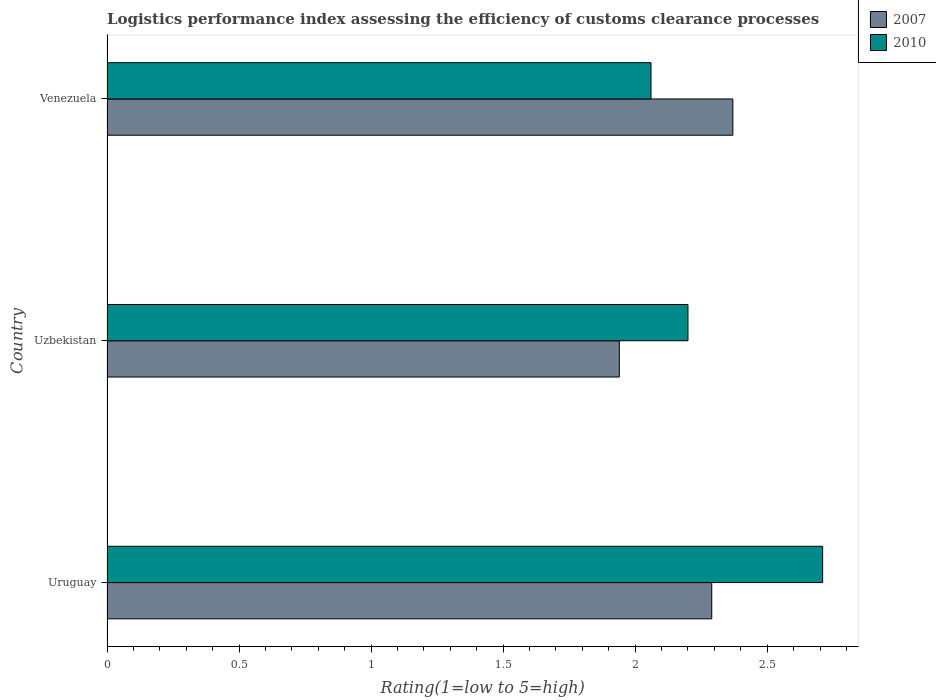How many different coloured bars are there?
Provide a short and direct response. 2. How many groups of bars are there?
Provide a short and direct response. 3. Are the number of bars per tick equal to the number of legend labels?
Offer a very short reply. Yes. Are the number of bars on each tick of the Y-axis equal?
Provide a succinct answer. Yes. How many bars are there on the 1st tick from the top?
Make the answer very short. 2. How many bars are there on the 3rd tick from the bottom?
Offer a very short reply. 2. What is the label of the 1st group of bars from the top?
Make the answer very short. Venezuela. What is the Logistic performance index in 2007 in Venezuela?
Provide a short and direct response. 2.37. Across all countries, what is the maximum Logistic performance index in 2010?
Provide a short and direct response. 2.71. Across all countries, what is the minimum Logistic performance index in 2010?
Offer a very short reply. 2.06. In which country was the Logistic performance index in 2010 maximum?
Your response must be concise. Uruguay. In which country was the Logistic performance index in 2007 minimum?
Your response must be concise. Uzbekistan. What is the total Logistic performance index in 2007 in the graph?
Your response must be concise. 6.6. What is the difference between the Logistic performance index in 2010 in Uruguay and that in Uzbekistan?
Make the answer very short. 0.51. What is the difference between the Logistic performance index in 2007 in Venezuela and the Logistic performance index in 2010 in Uruguay?
Provide a short and direct response. -0.34. What is the average Logistic performance index in 2007 per country?
Your answer should be compact. 2.2. What is the difference between the Logistic performance index in 2007 and Logistic performance index in 2010 in Venezuela?
Ensure brevity in your answer.  0.31. In how many countries, is the Logistic performance index in 2007 greater than 2.3 ?
Provide a short and direct response. 1. What is the ratio of the Logistic performance index in 2007 in Uruguay to that in Venezuela?
Provide a succinct answer. 0.97. What is the difference between the highest and the second highest Logistic performance index in 2010?
Make the answer very short. 0.51. What is the difference between the highest and the lowest Logistic performance index in 2010?
Offer a very short reply. 0.65. In how many countries, is the Logistic performance index in 2007 greater than the average Logistic performance index in 2007 taken over all countries?
Your response must be concise. 2. Is the sum of the Logistic performance index in 2010 in Uruguay and Venezuela greater than the maximum Logistic performance index in 2007 across all countries?
Your answer should be compact. Yes. What does the 1st bar from the top in Venezuela represents?
Ensure brevity in your answer.  2010. What does the 2nd bar from the bottom in Uruguay represents?
Offer a very short reply. 2010. How many bars are there?
Provide a short and direct response. 6. Are the values on the major ticks of X-axis written in scientific E-notation?
Provide a succinct answer. No. Where does the legend appear in the graph?
Give a very brief answer. Top right. How many legend labels are there?
Provide a succinct answer. 2. How are the legend labels stacked?
Give a very brief answer. Vertical. What is the title of the graph?
Ensure brevity in your answer.  Logistics performance index assessing the efficiency of customs clearance processes. What is the label or title of the X-axis?
Offer a very short reply. Rating(1=low to 5=high). What is the label or title of the Y-axis?
Your answer should be compact. Country. What is the Rating(1=low to 5=high) of 2007 in Uruguay?
Make the answer very short. 2.29. What is the Rating(1=low to 5=high) in 2010 in Uruguay?
Offer a very short reply. 2.71. What is the Rating(1=low to 5=high) in 2007 in Uzbekistan?
Make the answer very short. 1.94. What is the Rating(1=low to 5=high) of 2007 in Venezuela?
Offer a very short reply. 2.37. What is the Rating(1=low to 5=high) of 2010 in Venezuela?
Your answer should be very brief. 2.06. Across all countries, what is the maximum Rating(1=low to 5=high) in 2007?
Give a very brief answer. 2.37. Across all countries, what is the maximum Rating(1=low to 5=high) in 2010?
Your response must be concise. 2.71. Across all countries, what is the minimum Rating(1=low to 5=high) in 2007?
Keep it short and to the point. 1.94. Across all countries, what is the minimum Rating(1=low to 5=high) in 2010?
Give a very brief answer. 2.06. What is the total Rating(1=low to 5=high) in 2007 in the graph?
Offer a very short reply. 6.6. What is the total Rating(1=low to 5=high) in 2010 in the graph?
Provide a succinct answer. 6.97. What is the difference between the Rating(1=low to 5=high) of 2007 in Uruguay and that in Uzbekistan?
Ensure brevity in your answer.  0.35. What is the difference between the Rating(1=low to 5=high) of 2010 in Uruguay and that in Uzbekistan?
Your response must be concise. 0.51. What is the difference between the Rating(1=low to 5=high) in 2007 in Uruguay and that in Venezuela?
Ensure brevity in your answer.  -0.08. What is the difference between the Rating(1=low to 5=high) in 2010 in Uruguay and that in Venezuela?
Ensure brevity in your answer.  0.65. What is the difference between the Rating(1=low to 5=high) of 2007 in Uzbekistan and that in Venezuela?
Keep it short and to the point. -0.43. What is the difference between the Rating(1=low to 5=high) of 2010 in Uzbekistan and that in Venezuela?
Your answer should be compact. 0.14. What is the difference between the Rating(1=low to 5=high) of 2007 in Uruguay and the Rating(1=low to 5=high) of 2010 in Uzbekistan?
Provide a succinct answer. 0.09. What is the difference between the Rating(1=low to 5=high) in 2007 in Uruguay and the Rating(1=low to 5=high) in 2010 in Venezuela?
Provide a succinct answer. 0.23. What is the difference between the Rating(1=low to 5=high) of 2007 in Uzbekistan and the Rating(1=low to 5=high) of 2010 in Venezuela?
Ensure brevity in your answer.  -0.12. What is the average Rating(1=low to 5=high) in 2010 per country?
Make the answer very short. 2.32. What is the difference between the Rating(1=low to 5=high) of 2007 and Rating(1=low to 5=high) of 2010 in Uruguay?
Give a very brief answer. -0.42. What is the difference between the Rating(1=low to 5=high) of 2007 and Rating(1=low to 5=high) of 2010 in Uzbekistan?
Offer a terse response. -0.26. What is the difference between the Rating(1=low to 5=high) in 2007 and Rating(1=low to 5=high) in 2010 in Venezuela?
Offer a terse response. 0.31. What is the ratio of the Rating(1=low to 5=high) in 2007 in Uruguay to that in Uzbekistan?
Give a very brief answer. 1.18. What is the ratio of the Rating(1=low to 5=high) in 2010 in Uruguay to that in Uzbekistan?
Your response must be concise. 1.23. What is the ratio of the Rating(1=low to 5=high) of 2007 in Uruguay to that in Venezuela?
Offer a terse response. 0.97. What is the ratio of the Rating(1=low to 5=high) of 2010 in Uruguay to that in Venezuela?
Your answer should be compact. 1.32. What is the ratio of the Rating(1=low to 5=high) of 2007 in Uzbekistan to that in Venezuela?
Ensure brevity in your answer.  0.82. What is the ratio of the Rating(1=low to 5=high) in 2010 in Uzbekistan to that in Venezuela?
Make the answer very short. 1.07. What is the difference between the highest and the second highest Rating(1=low to 5=high) of 2010?
Keep it short and to the point. 0.51. What is the difference between the highest and the lowest Rating(1=low to 5=high) in 2007?
Your answer should be very brief. 0.43. What is the difference between the highest and the lowest Rating(1=low to 5=high) of 2010?
Offer a terse response. 0.65. 